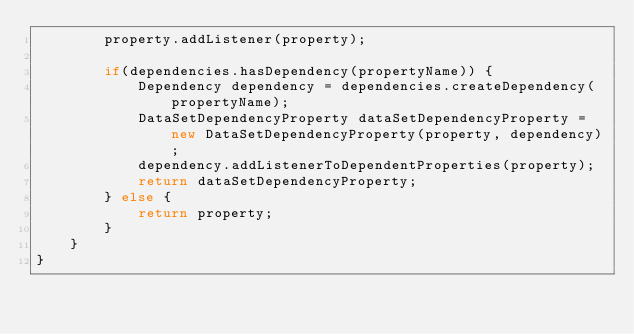Convert code to text. <code><loc_0><loc_0><loc_500><loc_500><_Java_>		property.addListener(property);
		
		if(dependencies.hasDependency(propertyName)) {
			Dependency dependency = dependencies.createDependency(propertyName);
			DataSetDependencyProperty dataSetDependencyProperty = new DataSetDependencyProperty(property, dependency);
			dependency.addListenerToDependentProperties(property);
			return dataSetDependencyProperty;
		} else {
			return property;
		}
	}
}
</code> 